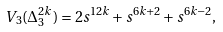<formula> <loc_0><loc_0><loc_500><loc_500>V _ { 3 } ( \Delta _ { 3 } ^ { 2 k } ) = 2 s ^ { 1 2 k } + s ^ { 6 k + 2 } + s ^ { 6 k - 2 } ,</formula> 